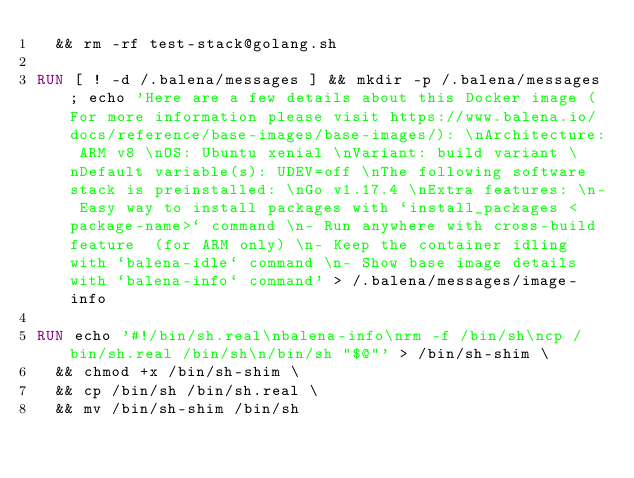Convert code to text. <code><loc_0><loc_0><loc_500><loc_500><_Dockerfile_>  && rm -rf test-stack@golang.sh 

RUN [ ! -d /.balena/messages ] && mkdir -p /.balena/messages; echo 'Here are a few details about this Docker image (For more information please visit https://www.balena.io/docs/reference/base-images/base-images/): \nArchitecture: ARM v8 \nOS: Ubuntu xenial \nVariant: build variant \nDefault variable(s): UDEV=off \nThe following software stack is preinstalled: \nGo v1.17.4 \nExtra features: \n- Easy way to install packages with `install_packages <package-name>` command \n- Run anywhere with cross-build feature  (for ARM only) \n- Keep the container idling with `balena-idle` command \n- Show base image details with `balena-info` command' > /.balena/messages/image-info

RUN echo '#!/bin/sh.real\nbalena-info\nrm -f /bin/sh\ncp /bin/sh.real /bin/sh\n/bin/sh "$@"' > /bin/sh-shim \
	&& chmod +x /bin/sh-shim \
	&& cp /bin/sh /bin/sh.real \
	&& mv /bin/sh-shim /bin/sh</code> 